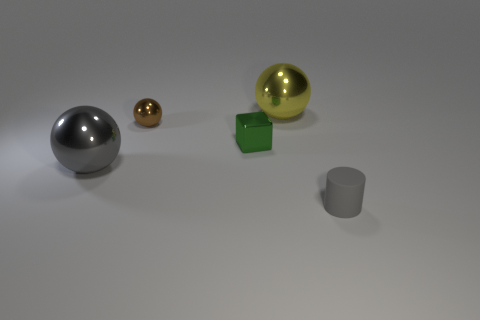Subtract 1 balls. How many balls are left? 2 Add 4 small purple matte blocks. How many objects exist? 9 Subtract 0 cyan balls. How many objects are left? 5 Subtract all cylinders. How many objects are left? 4 Subtract all big yellow objects. Subtract all big gray shiny things. How many objects are left? 3 Add 2 green shiny objects. How many green shiny objects are left? 3 Add 5 green things. How many green things exist? 6 